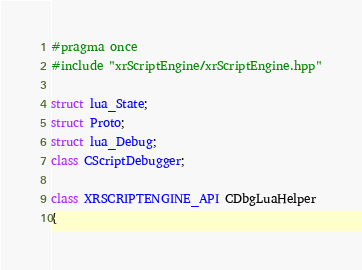Convert code to text. <code><loc_0><loc_0><loc_500><loc_500><_C++_>#pragma once
#include "xrScriptEngine/xrScriptEngine.hpp"

struct lua_State;
struct Proto;
struct lua_Debug;
class CScriptDebugger;

class XRSCRIPTENGINE_API CDbgLuaHelper
{</code> 